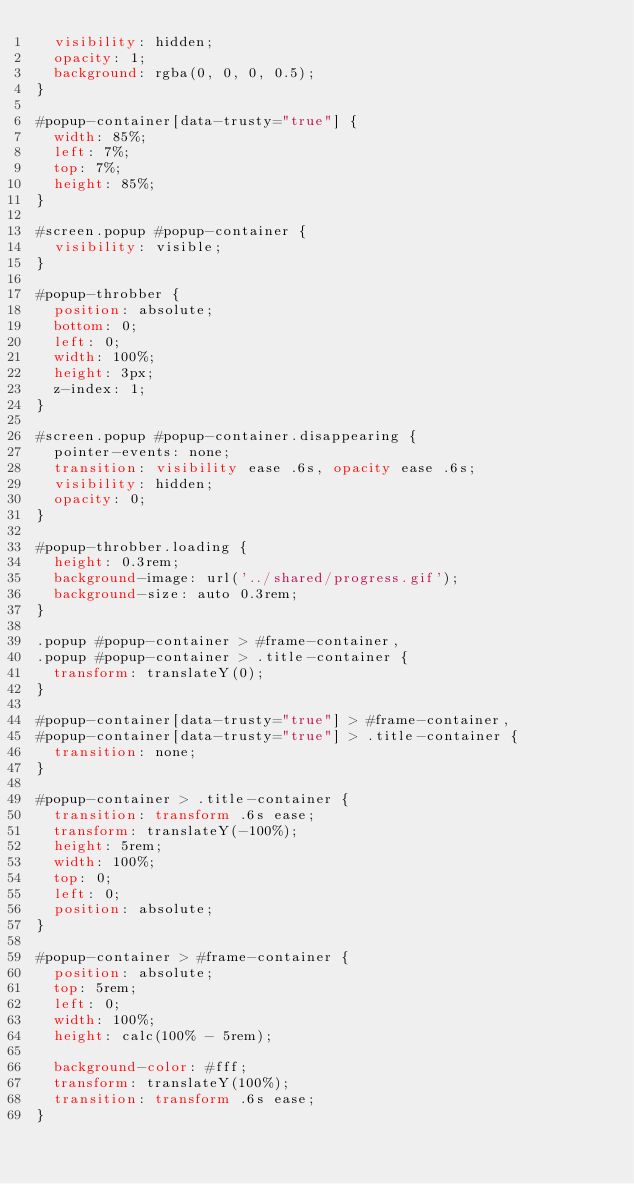Convert code to text. <code><loc_0><loc_0><loc_500><loc_500><_CSS_>  visibility: hidden;
  opacity: 1;
  background: rgba(0, 0, 0, 0.5);
}

#popup-container[data-trusty="true"] {
  width: 85%;
  left: 7%;
  top: 7%;
  height: 85%;
}

#screen.popup #popup-container {
  visibility: visible;
}

#popup-throbber {
  position: absolute;
  bottom: 0;
  left: 0;
  width: 100%;
  height: 3px;
  z-index: 1;
}

#screen.popup #popup-container.disappearing {
  pointer-events: none;
  transition: visibility ease .6s, opacity ease .6s;
  visibility: hidden;
  opacity: 0;
}

#popup-throbber.loading {
  height: 0.3rem;
  background-image: url('../shared/progress.gif');
  background-size: auto 0.3rem;
}

.popup #popup-container > #frame-container,
.popup #popup-container > .title-container {
  transform: translateY(0);
}

#popup-container[data-trusty="true"] > #frame-container,
#popup-container[data-trusty="true"] > .title-container {
  transition: none;
}

#popup-container > .title-container {
  transition: transform .6s ease;
  transform: translateY(-100%);
  height: 5rem;
  width: 100%;
  top: 0;
  left: 0;
  position: absolute;
}

#popup-container > #frame-container {
  position: absolute;
  top: 5rem;
  left: 0;
  width: 100%;
  height: calc(100% - 5rem);

  background-color: #fff;
  transform: translateY(100%);
  transition: transform .6s ease;
}
</code> 